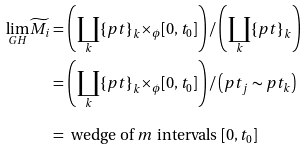Convert formula to latex. <formula><loc_0><loc_0><loc_500><loc_500>\underset { G H } { \lim } \widetilde { M _ { i } } & = \left ( \underset { k } { \coprod } { \{ p t \} } _ { k } { \times } _ { \phi } [ 0 , t _ { 0 } ] \right ) / \left ( \underset { k } { \coprod } { \{ p t \} } _ { k } \right ) \\ & = \left ( \underset { k } { \coprod } { \{ p t \} } _ { k } { \times } _ { \phi } [ 0 , t _ { 0 } ] \right ) / \left ( p t _ { j } \sim p t _ { k } \right ) \\ & = \text { wedge of $m$ intervals $[0,t_{0}]$ }</formula> 